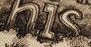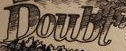What words are shown in these images in order, separated by a semicolon? his; Doubt 